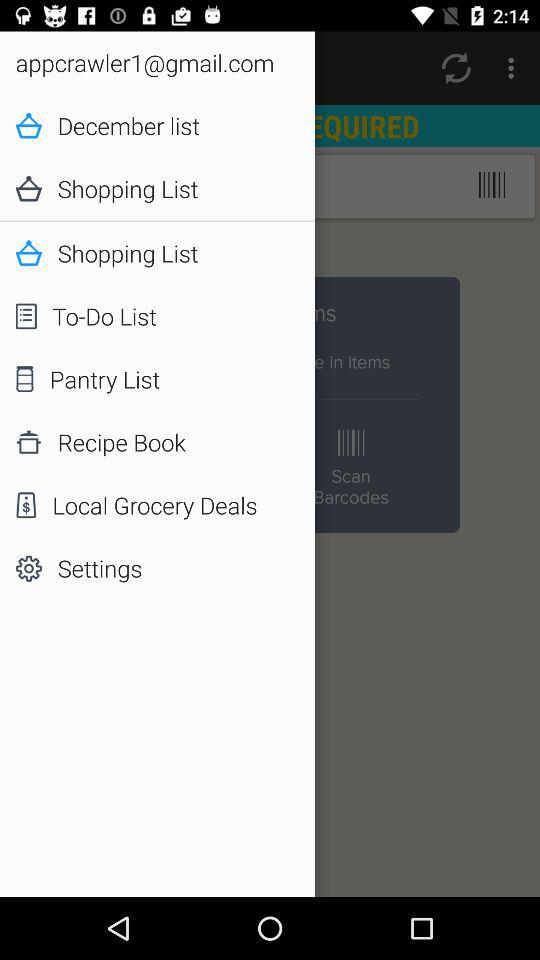What is the email address of the user? The email address is appcrawler1@gmail.com. 